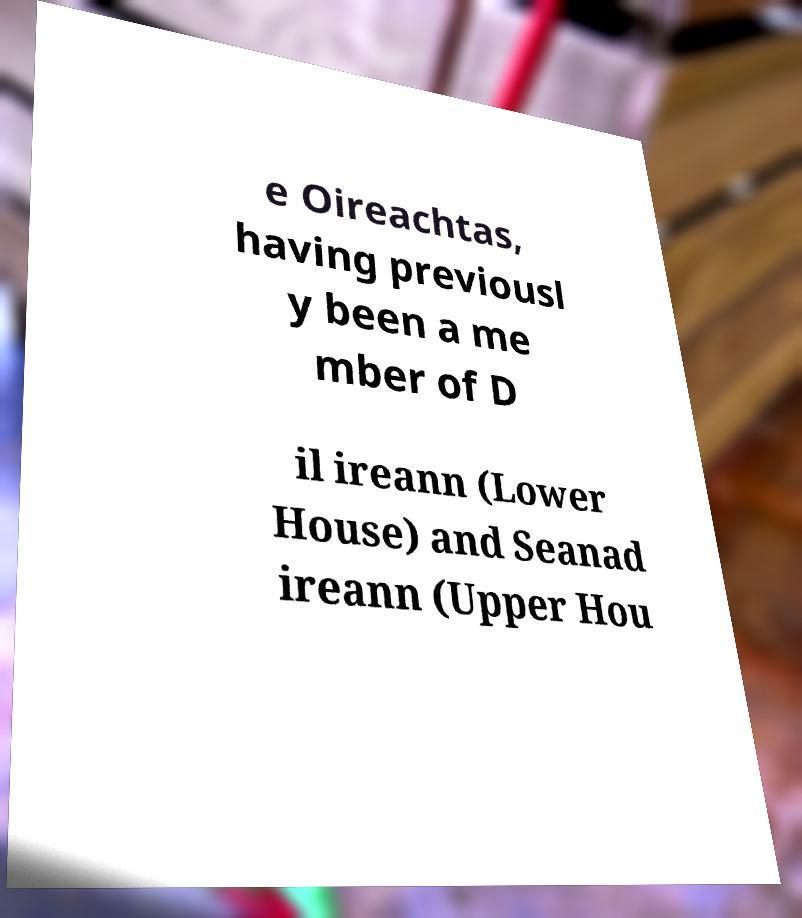Please read and relay the text visible in this image. What does it say? e Oireachtas, having previousl y been a me mber of D il ireann (Lower House) and Seanad ireann (Upper Hou 